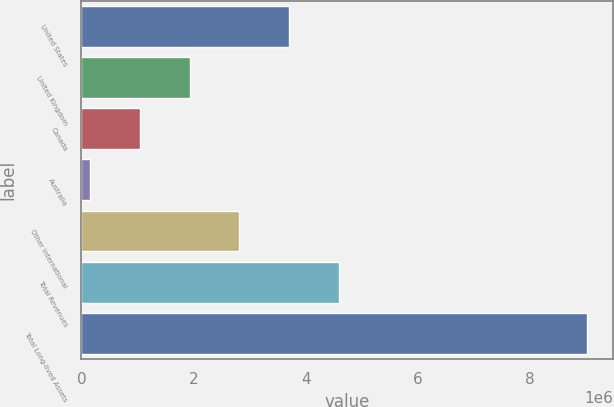Convert chart. <chart><loc_0><loc_0><loc_500><loc_500><bar_chart><fcel>United States<fcel>United Kingdom<fcel>Canada<fcel>Australia<fcel>Other International<fcel>Total Revenues<fcel>Total Long-lived Assets<nl><fcel>3.70323e+06<fcel>1.93028e+06<fcel>1.04381e+06<fcel>157333<fcel>2.81676e+06<fcel>4.58971e+06<fcel>9.02209e+06<nl></chart> 